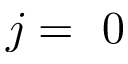<formula> <loc_0><loc_0><loc_500><loc_500>j = 0</formula> 